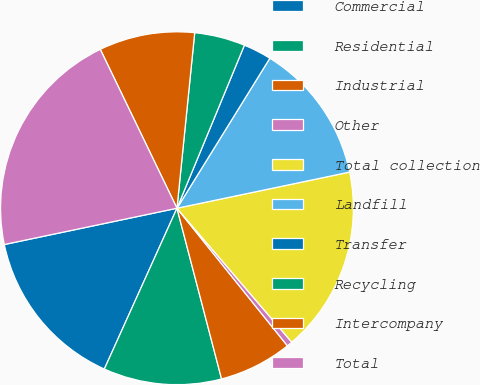Convert chart. <chart><loc_0><loc_0><loc_500><loc_500><pie_chart><fcel>Commercial<fcel>Residential<fcel>Industrial<fcel>Other<fcel>Total collection<fcel>Landfill<fcel>Transfer<fcel>Recycling<fcel>Intercompany<fcel>Total<nl><fcel>14.95%<fcel>10.82%<fcel>6.7%<fcel>0.51%<fcel>17.01%<fcel>12.89%<fcel>2.58%<fcel>4.64%<fcel>8.76%<fcel>21.14%<nl></chart> 